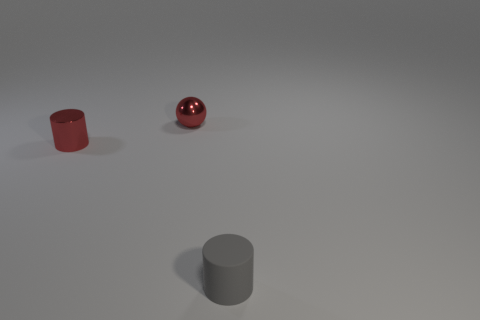Add 3 large red matte objects. How many objects exist? 6 Subtract all cylinders. How many objects are left? 1 Add 1 tiny gray rubber things. How many tiny gray rubber things exist? 2 Subtract 0 green blocks. How many objects are left? 3 Subtract all gray rubber cylinders. Subtract all red cylinders. How many objects are left? 1 Add 1 small red shiny spheres. How many small red shiny spheres are left? 2 